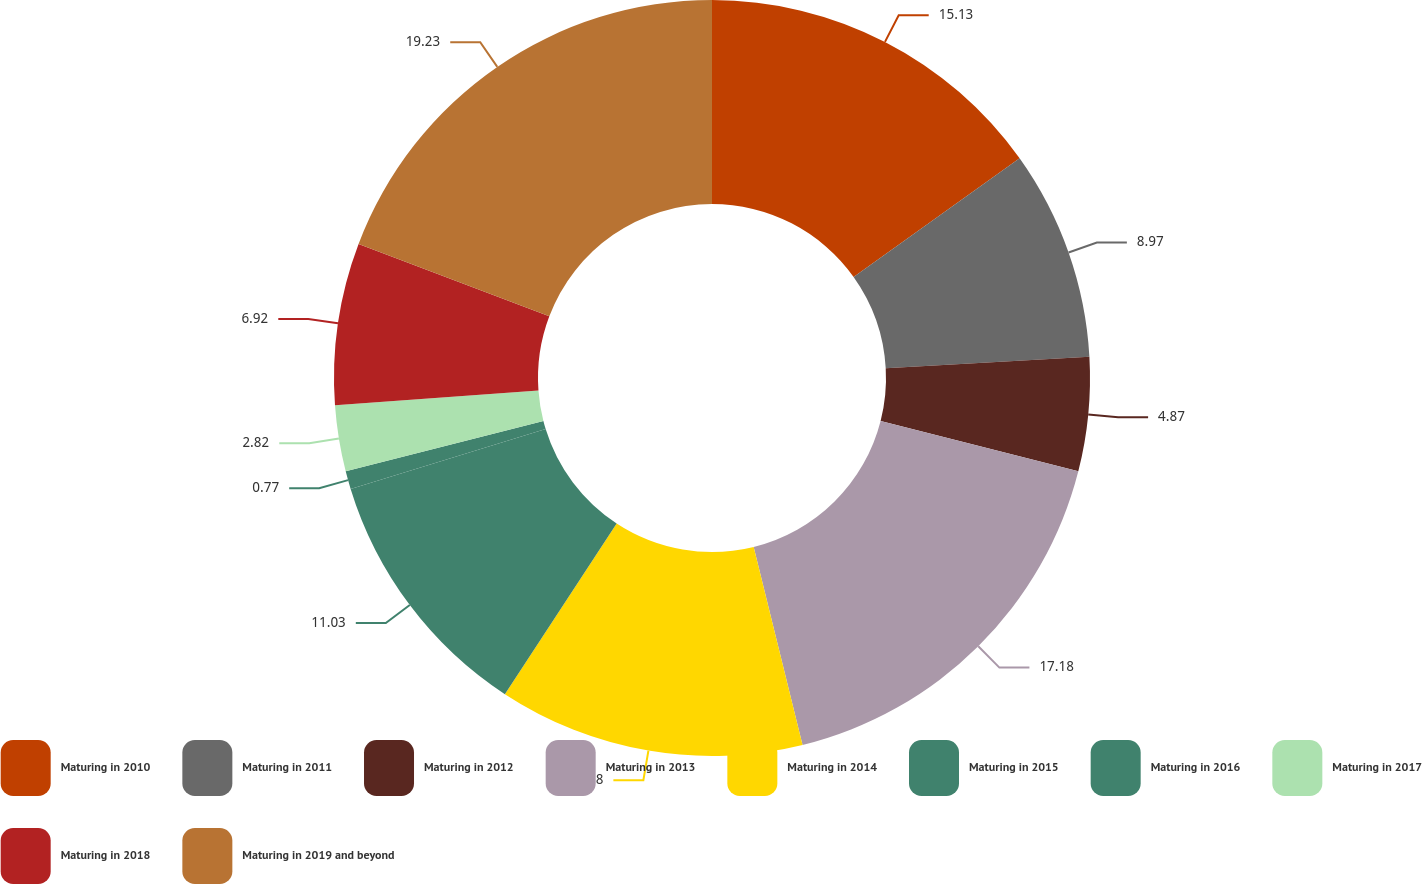Convert chart. <chart><loc_0><loc_0><loc_500><loc_500><pie_chart><fcel>Maturing in 2010<fcel>Maturing in 2011<fcel>Maturing in 2012<fcel>Maturing in 2013<fcel>Maturing in 2014<fcel>Maturing in 2015<fcel>Maturing in 2016<fcel>Maturing in 2017<fcel>Maturing in 2018<fcel>Maturing in 2019 and beyond<nl><fcel>15.13%<fcel>8.97%<fcel>4.87%<fcel>17.18%<fcel>13.08%<fcel>11.03%<fcel>0.77%<fcel>2.82%<fcel>6.92%<fcel>19.23%<nl></chart> 